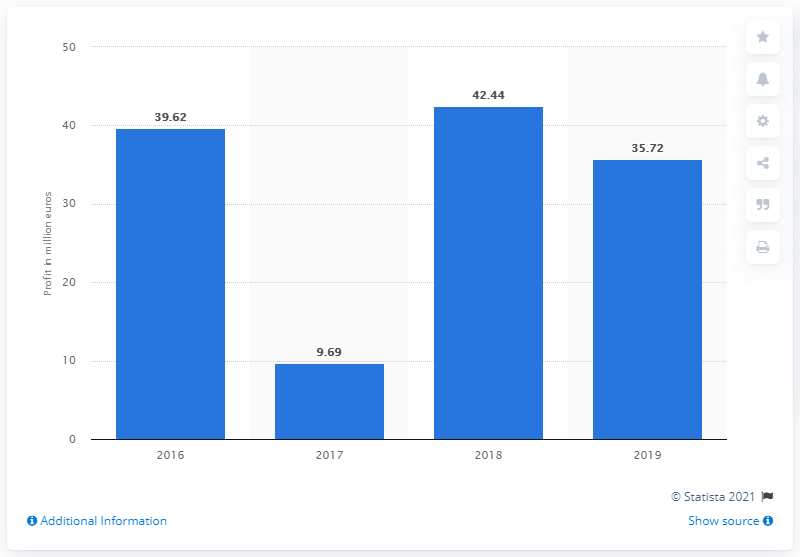Specify some key components in this picture. ACS Dobfar's profit in 2017 was 9.69. 